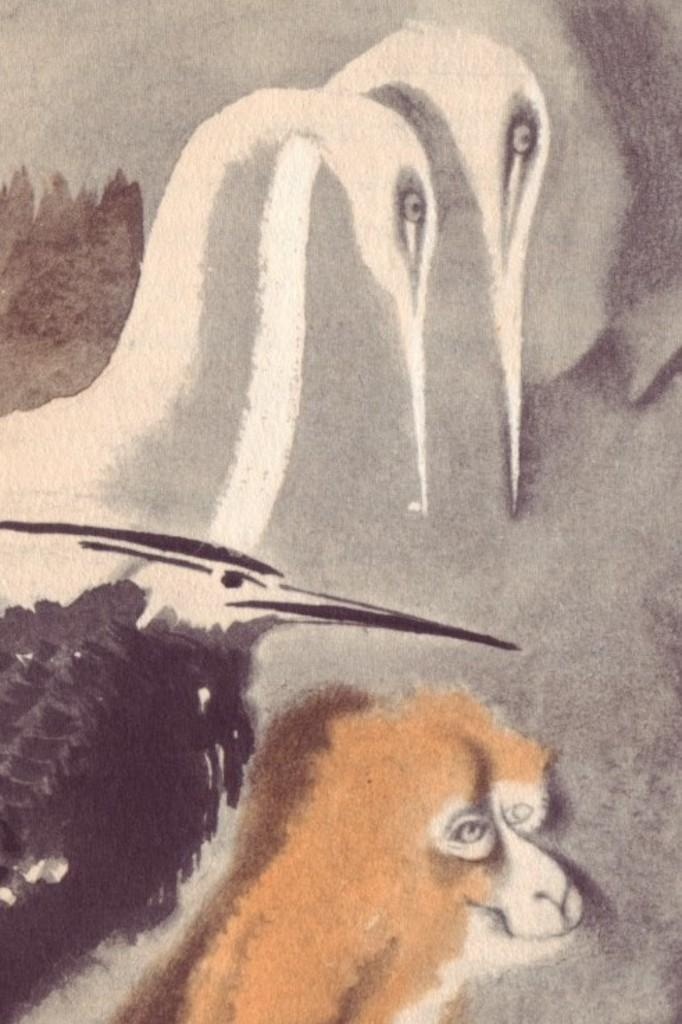What type of animals are depicted in the painting? There are birds and a monkey in the painting. Can you describe the setting or environment in the painting? The provided facts do not mention the setting or environment in the painting. What type of ink is used to create the painting? The provided facts do not mention the type of ink used to create the painting. What color is the dress worn by the monkey in the painting? There is no mention of a dress in the painting, as the monkey is not wearing any clothing. 